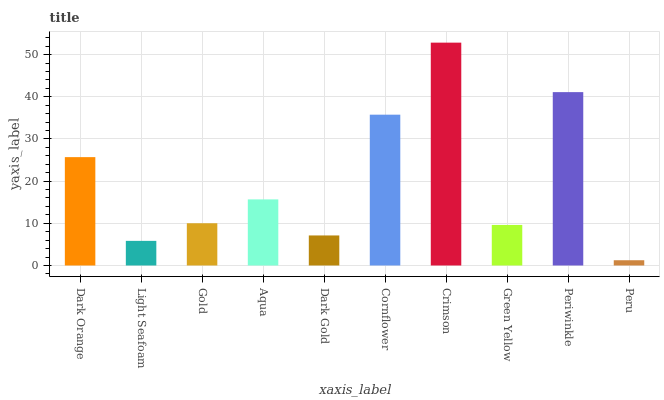Is Peru the minimum?
Answer yes or no. Yes. Is Crimson the maximum?
Answer yes or no. Yes. Is Light Seafoam the minimum?
Answer yes or no. No. Is Light Seafoam the maximum?
Answer yes or no. No. Is Dark Orange greater than Light Seafoam?
Answer yes or no. Yes. Is Light Seafoam less than Dark Orange?
Answer yes or no. Yes. Is Light Seafoam greater than Dark Orange?
Answer yes or no. No. Is Dark Orange less than Light Seafoam?
Answer yes or no. No. Is Aqua the high median?
Answer yes or no. Yes. Is Gold the low median?
Answer yes or no. Yes. Is Periwinkle the high median?
Answer yes or no. No. Is Peru the low median?
Answer yes or no. No. 